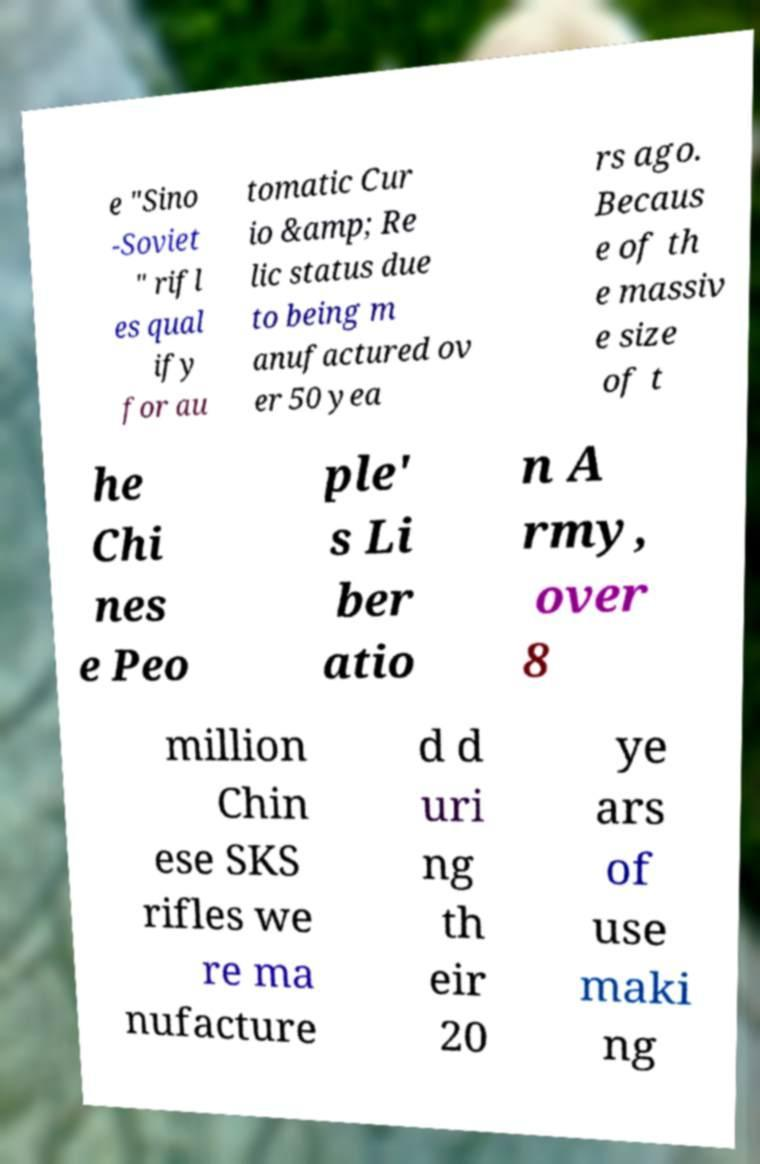There's text embedded in this image that I need extracted. Can you transcribe it verbatim? e "Sino -Soviet " rifl es qual ify for au tomatic Cur io &amp; Re lic status due to being m anufactured ov er 50 yea rs ago. Becaus e of th e massiv e size of t he Chi nes e Peo ple' s Li ber atio n A rmy, over 8 million Chin ese SKS rifles we re ma nufacture d d uri ng th eir 20 ye ars of use maki ng 